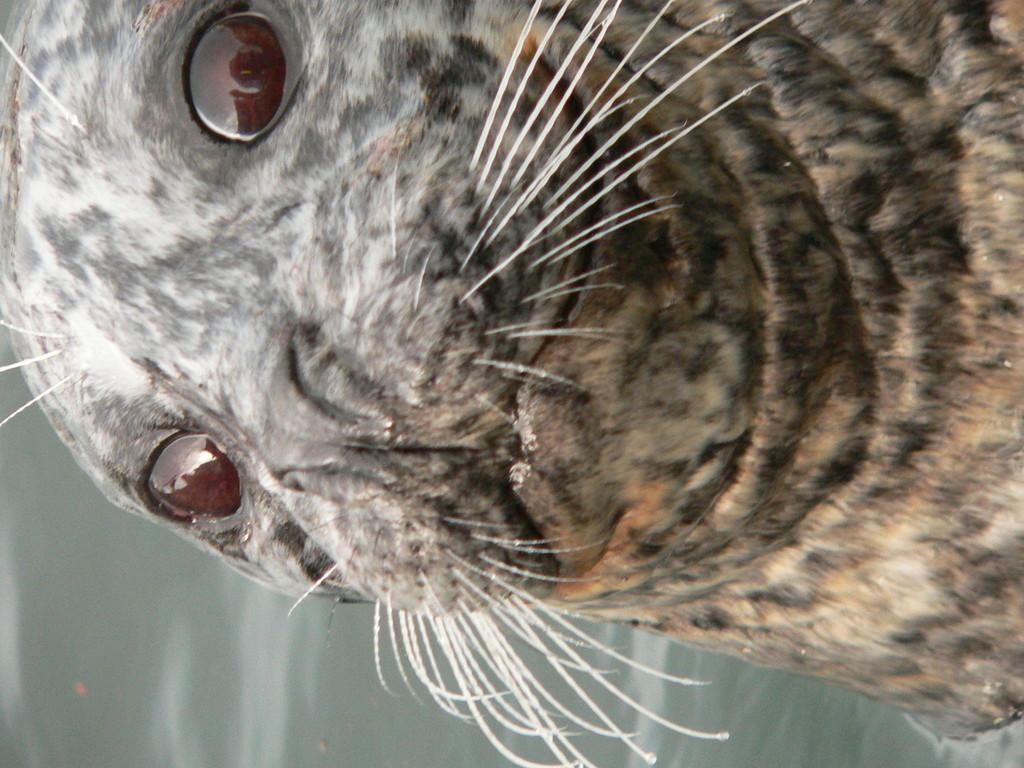In one or two sentences, can you explain what this image depicts? In the image we can see there is a seal in the water. 